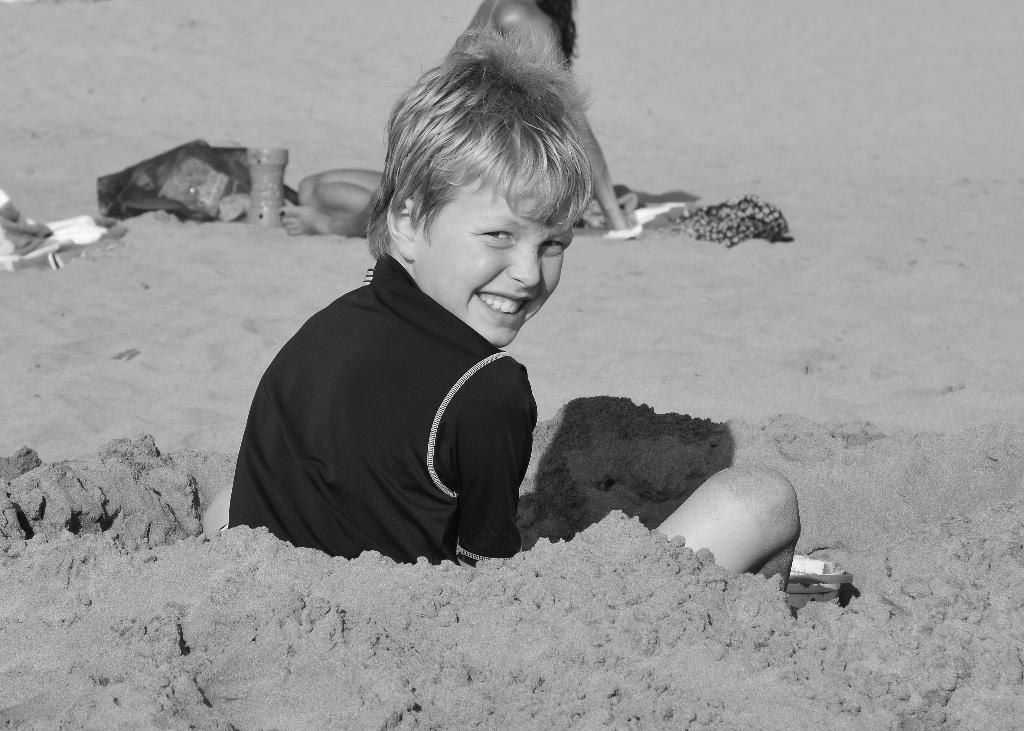Please provide a concise description of this image. In this picture we can see a child sitting on sand and smiling and in the background we can see a woman, clothes and some objects. 